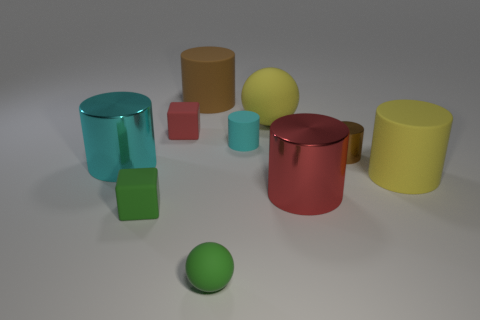Describe the arrangement of the objects in relation to each other. The objects are spread out across the surface, with varying shapes like cylinders and cubes suggesting a deliberate casual arrangement with no apparent pattern. 